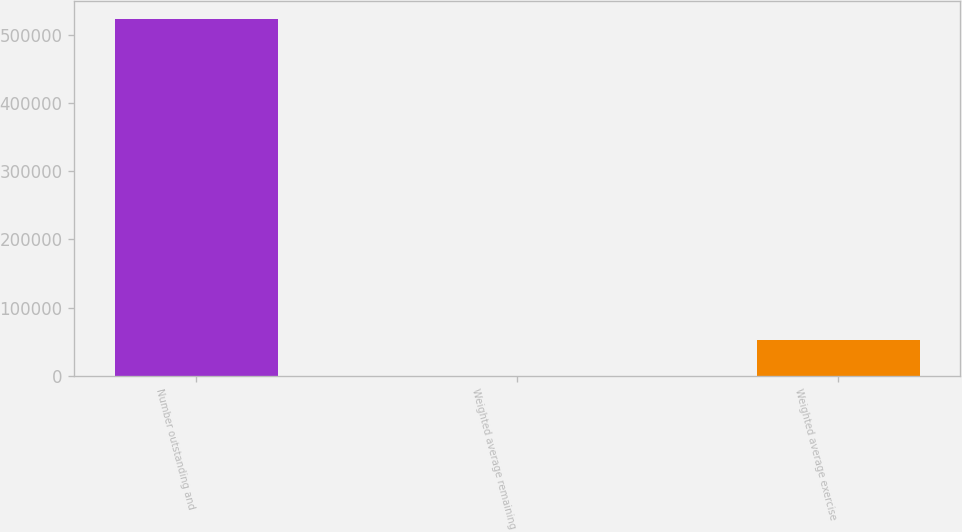<chart> <loc_0><loc_0><loc_500><loc_500><bar_chart><fcel>Number outstanding and<fcel>Weighted average remaining<fcel>Weighted average exercise<nl><fcel>523083<fcel>2.5<fcel>52310.6<nl></chart> 